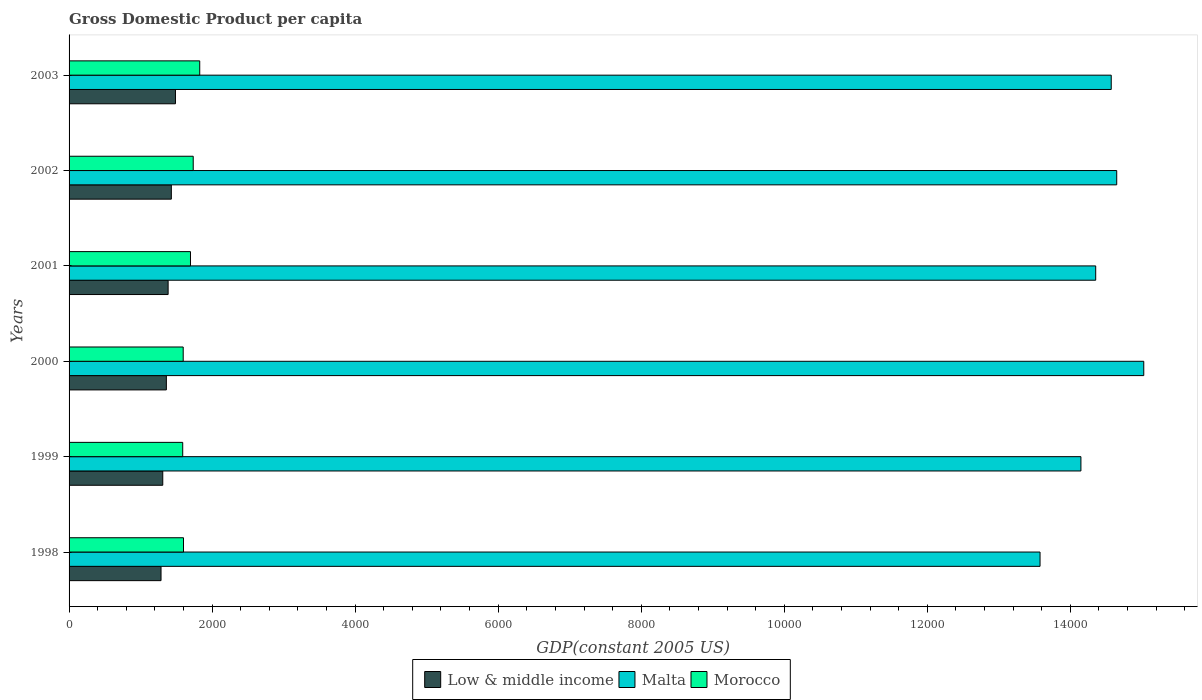How many groups of bars are there?
Your answer should be very brief. 6. Are the number of bars per tick equal to the number of legend labels?
Your answer should be very brief. Yes. Are the number of bars on each tick of the Y-axis equal?
Offer a very short reply. Yes. How many bars are there on the 6th tick from the top?
Your response must be concise. 3. How many bars are there on the 3rd tick from the bottom?
Your response must be concise. 3. In how many cases, is the number of bars for a given year not equal to the number of legend labels?
Make the answer very short. 0. What is the GDP per capita in Low & middle income in 2002?
Make the answer very short. 1430.07. Across all years, what is the maximum GDP per capita in Low & middle income?
Offer a terse response. 1487.72. Across all years, what is the minimum GDP per capita in Morocco?
Give a very brief answer. 1588.98. In which year was the GDP per capita in Low & middle income maximum?
Provide a succinct answer. 2003. What is the total GDP per capita in Morocco in the graph?
Your answer should be very brief. 1.00e+04. What is the difference between the GDP per capita in Low & middle income in 1998 and that in 2002?
Make the answer very short. -144.21. What is the difference between the GDP per capita in Morocco in 1998 and the GDP per capita in Low & middle income in 1999?
Provide a succinct answer. 289.92. What is the average GDP per capita in Morocco per year?
Offer a very short reply. 1674.18. In the year 1998, what is the difference between the GDP per capita in Malta and GDP per capita in Morocco?
Offer a terse response. 1.20e+04. In how many years, is the GDP per capita in Low & middle income greater than 6800 US$?
Provide a succinct answer. 0. What is the ratio of the GDP per capita in Malta in 1998 to that in 1999?
Give a very brief answer. 0.96. Is the GDP per capita in Morocco in 2000 less than that in 2003?
Provide a short and direct response. Yes. What is the difference between the highest and the second highest GDP per capita in Malta?
Your answer should be compact. 377.99. What is the difference between the highest and the lowest GDP per capita in Low & middle income?
Offer a terse response. 201.86. Is the sum of the GDP per capita in Malta in 1999 and 2002 greater than the maximum GDP per capita in Low & middle income across all years?
Your answer should be very brief. Yes. What does the 1st bar from the top in 1999 represents?
Provide a short and direct response. Morocco. What does the 3rd bar from the bottom in 2003 represents?
Offer a terse response. Morocco. Is it the case that in every year, the sum of the GDP per capita in Morocco and GDP per capita in Low & middle income is greater than the GDP per capita in Malta?
Ensure brevity in your answer.  No. How many bars are there?
Provide a succinct answer. 18. Are all the bars in the graph horizontal?
Give a very brief answer. Yes. Are the values on the major ticks of X-axis written in scientific E-notation?
Give a very brief answer. No. Does the graph contain grids?
Provide a short and direct response. No. How are the legend labels stacked?
Provide a short and direct response. Horizontal. What is the title of the graph?
Your response must be concise. Gross Domestic Product per capita. What is the label or title of the X-axis?
Make the answer very short. GDP(constant 2005 US). What is the GDP(constant 2005 US) in Low & middle income in 1998?
Offer a very short reply. 1285.86. What is the GDP(constant 2005 US) of Malta in 1998?
Offer a very short reply. 1.36e+04. What is the GDP(constant 2005 US) of Morocco in 1998?
Keep it short and to the point. 1600.02. What is the GDP(constant 2005 US) of Low & middle income in 1999?
Make the answer very short. 1310.1. What is the GDP(constant 2005 US) in Malta in 1999?
Your response must be concise. 1.41e+04. What is the GDP(constant 2005 US) of Morocco in 1999?
Your answer should be very brief. 1588.98. What is the GDP(constant 2005 US) of Low & middle income in 2000?
Your answer should be compact. 1360.25. What is the GDP(constant 2005 US) in Malta in 2000?
Offer a terse response. 1.50e+04. What is the GDP(constant 2005 US) of Morocco in 2000?
Keep it short and to the point. 1595.77. What is the GDP(constant 2005 US) in Low & middle income in 2001?
Ensure brevity in your answer.  1385.02. What is the GDP(constant 2005 US) of Malta in 2001?
Offer a very short reply. 1.44e+04. What is the GDP(constant 2005 US) in Morocco in 2001?
Provide a succinct answer. 1697.64. What is the GDP(constant 2005 US) of Low & middle income in 2002?
Give a very brief answer. 1430.07. What is the GDP(constant 2005 US) of Malta in 2002?
Provide a succinct answer. 1.46e+04. What is the GDP(constant 2005 US) of Morocco in 2002?
Your answer should be very brief. 1735.79. What is the GDP(constant 2005 US) in Low & middle income in 2003?
Your answer should be compact. 1487.72. What is the GDP(constant 2005 US) of Malta in 2003?
Give a very brief answer. 1.46e+04. What is the GDP(constant 2005 US) in Morocco in 2003?
Keep it short and to the point. 1826.87. Across all years, what is the maximum GDP(constant 2005 US) of Low & middle income?
Your answer should be very brief. 1487.72. Across all years, what is the maximum GDP(constant 2005 US) of Malta?
Ensure brevity in your answer.  1.50e+04. Across all years, what is the maximum GDP(constant 2005 US) in Morocco?
Your answer should be very brief. 1826.87. Across all years, what is the minimum GDP(constant 2005 US) of Low & middle income?
Offer a very short reply. 1285.86. Across all years, what is the minimum GDP(constant 2005 US) of Malta?
Offer a terse response. 1.36e+04. Across all years, what is the minimum GDP(constant 2005 US) in Morocco?
Offer a very short reply. 1588.98. What is the total GDP(constant 2005 US) in Low & middle income in the graph?
Your response must be concise. 8259.01. What is the total GDP(constant 2005 US) of Malta in the graph?
Your answer should be very brief. 8.63e+04. What is the total GDP(constant 2005 US) in Morocco in the graph?
Make the answer very short. 1.00e+04. What is the difference between the GDP(constant 2005 US) of Low & middle income in 1998 and that in 1999?
Offer a very short reply. -24.24. What is the difference between the GDP(constant 2005 US) of Malta in 1998 and that in 1999?
Your answer should be compact. -571.69. What is the difference between the GDP(constant 2005 US) in Morocco in 1998 and that in 1999?
Provide a succinct answer. 11.04. What is the difference between the GDP(constant 2005 US) in Low & middle income in 1998 and that in 2000?
Provide a succinct answer. -74.39. What is the difference between the GDP(constant 2005 US) in Malta in 1998 and that in 2000?
Make the answer very short. -1450.21. What is the difference between the GDP(constant 2005 US) in Morocco in 1998 and that in 2000?
Offer a very short reply. 4.25. What is the difference between the GDP(constant 2005 US) of Low & middle income in 1998 and that in 2001?
Provide a succinct answer. -99.16. What is the difference between the GDP(constant 2005 US) of Malta in 1998 and that in 2001?
Provide a succinct answer. -778.24. What is the difference between the GDP(constant 2005 US) in Morocco in 1998 and that in 2001?
Your answer should be compact. -97.62. What is the difference between the GDP(constant 2005 US) of Low & middle income in 1998 and that in 2002?
Provide a succinct answer. -144.21. What is the difference between the GDP(constant 2005 US) of Malta in 1998 and that in 2002?
Provide a short and direct response. -1072.21. What is the difference between the GDP(constant 2005 US) in Morocco in 1998 and that in 2002?
Give a very brief answer. -135.77. What is the difference between the GDP(constant 2005 US) of Low & middle income in 1998 and that in 2003?
Give a very brief answer. -201.86. What is the difference between the GDP(constant 2005 US) of Malta in 1998 and that in 2003?
Provide a short and direct response. -995.4. What is the difference between the GDP(constant 2005 US) of Morocco in 1998 and that in 2003?
Your answer should be very brief. -226.85. What is the difference between the GDP(constant 2005 US) in Low & middle income in 1999 and that in 2000?
Make the answer very short. -50.15. What is the difference between the GDP(constant 2005 US) of Malta in 1999 and that in 2000?
Provide a succinct answer. -878.51. What is the difference between the GDP(constant 2005 US) of Morocco in 1999 and that in 2000?
Your response must be concise. -6.78. What is the difference between the GDP(constant 2005 US) of Low & middle income in 1999 and that in 2001?
Your answer should be compact. -74.92. What is the difference between the GDP(constant 2005 US) of Malta in 1999 and that in 2001?
Ensure brevity in your answer.  -206.54. What is the difference between the GDP(constant 2005 US) of Morocco in 1999 and that in 2001?
Keep it short and to the point. -108.66. What is the difference between the GDP(constant 2005 US) of Low & middle income in 1999 and that in 2002?
Your answer should be compact. -119.97. What is the difference between the GDP(constant 2005 US) in Malta in 1999 and that in 2002?
Offer a very short reply. -500.52. What is the difference between the GDP(constant 2005 US) of Morocco in 1999 and that in 2002?
Your answer should be very brief. -146.81. What is the difference between the GDP(constant 2005 US) of Low & middle income in 1999 and that in 2003?
Your answer should be very brief. -177.62. What is the difference between the GDP(constant 2005 US) in Malta in 1999 and that in 2003?
Make the answer very short. -423.71. What is the difference between the GDP(constant 2005 US) of Morocco in 1999 and that in 2003?
Offer a terse response. -237.88. What is the difference between the GDP(constant 2005 US) of Low & middle income in 2000 and that in 2001?
Ensure brevity in your answer.  -24.77. What is the difference between the GDP(constant 2005 US) of Malta in 2000 and that in 2001?
Give a very brief answer. 671.97. What is the difference between the GDP(constant 2005 US) of Morocco in 2000 and that in 2001?
Give a very brief answer. -101.88. What is the difference between the GDP(constant 2005 US) in Low & middle income in 2000 and that in 2002?
Ensure brevity in your answer.  -69.82. What is the difference between the GDP(constant 2005 US) of Malta in 2000 and that in 2002?
Offer a very short reply. 377.99. What is the difference between the GDP(constant 2005 US) of Morocco in 2000 and that in 2002?
Make the answer very short. -140.02. What is the difference between the GDP(constant 2005 US) of Low & middle income in 2000 and that in 2003?
Your answer should be very brief. -127.47. What is the difference between the GDP(constant 2005 US) in Malta in 2000 and that in 2003?
Keep it short and to the point. 454.8. What is the difference between the GDP(constant 2005 US) of Morocco in 2000 and that in 2003?
Your answer should be very brief. -231.1. What is the difference between the GDP(constant 2005 US) in Low & middle income in 2001 and that in 2002?
Your answer should be compact. -45.05. What is the difference between the GDP(constant 2005 US) in Malta in 2001 and that in 2002?
Offer a terse response. -293.98. What is the difference between the GDP(constant 2005 US) of Morocco in 2001 and that in 2002?
Your response must be concise. -38.15. What is the difference between the GDP(constant 2005 US) of Low & middle income in 2001 and that in 2003?
Your answer should be very brief. -102.7. What is the difference between the GDP(constant 2005 US) in Malta in 2001 and that in 2003?
Keep it short and to the point. -217.17. What is the difference between the GDP(constant 2005 US) in Morocco in 2001 and that in 2003?
Keep it short and to the point. -129.22. What is the difference between the GDP(constant 2005 US) in Low & middle income in 2002 and that in 2003?
Offer a terse response. -57.65. What is the difference between the GDP(constant 2005 US) in Malta in 2002 and that in 2003?
Offer a terse response. 76.81. What is the difference between the GDP(constant 2005 US) of Morocco in 2002 and that in 2003?
Your response must be concise. -91.08. What is the difference between the GDP(constant 2005 US) in Low & middle income in 1998 and the GDP(constant 2005 US) in Malta in 1999?
Offer a terse response. -1.29e+04. What is the difference between the GDP(constant 2005 US) in Low & middle income in 1998 and the GDP(constant 2005 US) in Morocco in 1999?
Ensure brevity in your answer.  -303.12. What is the difference between the GDP(constant 2005 US) of Malta in 1998 and the GDP(constant 2005 US) of Morocco in 1999?
Keep it short and to the point. 1.20e+04. What is the difference between the GDP(constant 2005 US) in Low & middle income in 1998 and the GDP(constant 2005 US) in Malta in 2000?
Provide a short and direct response. -1.37e+04. What is the difference between the GDP(constant 2005 US) in Low & middle income in 1998 and the GDP(constant 2005 US) in Morocco in 2000?
Provide a succinct answer. -309.91. What is the difference between the GDP(constant 2005 US) of Malta in 1998 and the GDP(constant 2005 US) of Morocco in 2000?
Keep it short and to the point. 1.20e+04. What is the difference between the GDP(constant 2005 US) in Low & middle income in 1998 and the GDP(constant 2005 US) in Malta in 2001?
Provide a short and direct response. -1.31e+04. What is the difference between the GDP(constant 2005 US) in Low & middle income in 1998 and the GDP(constant 2005 US) in Morocco in 2001?
Offer a terse response. -411.78. What is the difference between the GDP(constant 2005 US) in Malta in 1998 and the GDP(constant 2005 US) in Morocco in 2001?
Give a very brief answer. 1.19e+04. What is the difference between the GDP(constant 2005 US) in Low & middle income in 1998 and the GDP(constant 2005 US) in Malta in 2002?
Your answer should be compact. -1.34e+04. What is the difference between the GDP(constant 2005 US) in Low & middle income in 1998 and the GDP(constant 2005 US) in Morocco in 2002?
Your answer should be compact. -449.93. What is the difference between the GDP(constant 2005 US) in Malta in 1998 and the GDP(constant 2005 US) in Morocco in 2002?
Your answer should be very brief. 1.18e+04. What is the difference between the GDP(constant 2005 US) of Low & middle income in 1998 and the GDP(constant 2005 US) of Malta in 2003?
Ensure brevity in your answer.  -1.33e+04. What is the difference between the GDP(constant 2005 US) of Low & middle income in 1998 and the GDP(constant 2005 US) of Morocco in 2003?
Your response must be concise. -541.01. What is the difference between the GDP(constant 2005 US) of Malta in 1998 and the GDP(constant 2005 US) of Morocco in 2003?
Provide a short and direct response. 1.17e+04. What is the difference between the GDP(constant 2005 US) in Low & middle income in 1999 and the GDP(constant 2005 US) in Malta in 2000?
Make the answer very short. -1.37e+04. What is the difference between the GDP(constant 2005 US) in Low & middle income in 1999 and the GDP(constant 2005 US) in Morocco in 2000?
Offer a terse response. -285.67. What is the difference between the GDP(constant 2005 US) in Malta in 1999 and the GDP(constant 2005 US) in Morocco in 2000?
Your answer should be compact. 1.26e+04. What is the difference between the GDP(constant 2005 US) of Low & middle income in 1999 and the GDP(constant 2005 US) of Malta in 2001?
Give a very brief answer. -1.30e+04. What is the difference between the GDP(constant 2005 US) in Low & middle income in 1999 and the GDP(constant 2005 US) in Morocco in 2001?
Your answer should be very brief. -387.55. What is the difference between the GDP(constant 2005 US) in Malta in 1999 and the GDP(constant 2005 US) in Morocco in 2001?
Offer a very short reply. 1.25e+04. What is the difference between the GDP(constant 2005 US) of Low & middle income in 1999 and the GDP(constant 2005 US) of Malta in 2002?
Offer a very short reply. -1.33e+04. What is the difference between the GDP(constant 2005 US) in Low & middle income in 1999 and the GDP(constant 2005 US) in Morocco in 2002?
Your answer should be very brief. -425.69. What is the difference between the GDP(constant 2005 US) of Malta in 1999 and the GDP(constant 2005 US) of Morocco in 2002?
Provide a succinct answer. 1.24e+04. What is the difference between the GDP(constant 2005 US) of Low & middle income in 1999 and the GDP(constant 2005 US) of Malta in 2003?
Give a very brief answer. -1.33e+04. What is the difference between the GDP(constant 2005 US) of Low & middle income in 1999 and the GDP(constant 2005 US) of Morocco in 2003?
Your answer should be very brief. -516.77. What is the difference between the GDP(constant 2005 US) of Malta in 1999 and the GDP(constant 2005 US) of Morocco in 2003?
Provide a succinct answer. 1.23e+04. What is the difference between the GDP(constant 2005 US) of Low & middle income in 2000 and the GDP(constant 2005 US) of Malta in 2001?
Keep it short and to the point. -1.30e+04. What is the difference between the GDP(constant 2005 US) of Low & middle income in 2000 and the GDP(constant 2005 US) of Morocco in 2001?
Offer a very short reply. -337.4. What is the difference between the GDP(constant 2005 US) of Malta in 2000 and the GDP(constant 2005 US) of Morocco in 2001?
Provide a short and direct response. 1.33e+04. What is the difference between the GDP(constant 2005 US) in Low & middle income in 2000 and the GDP(constant 2005 US) in Malta in 2002?
Your answer should be compact. -1.33e+04. What is the difference between the GDP(constant 2005 US) of Low & middle income in 2000 and the GDP(constant 2005 US) of Morocco in 2002?
Give a very brief answer. -375.54. What is the difference between the GDP(constant 2005 US) of Malta in 2000 and the GDP(constant 2005 US) of Morocco in 2002?
Offer a very short reply. 1.33e+04. What is the difference between the GDP(constant 2005 US) of Low & middle income in 2000 and the GDP(constant 2005 US) of Malta in 2003?
Your answer should be compact. -1.32e+04. What is the difference between the GDP(constant 2005 US) in Low & middle income in 2000 and the GDP(constant 2005 US) in Morocco in 2003?
Offer a very short reply. -466.62. What is the difference between the GDP(constant 2005 US) in Malta in 2000 and the GDP(constant 2005 US) in Morocco in 2003?
Make the answer very short. 1.32e+04. What is the difference between the GDP(constant 2005 US) in Low & middle income in 2001 and the GDP(constant 2005 US) in Malta in 2002?
Your answer should be compact. -1.33e+04. What is the difference between the GDP(constant 2005 US) of Low & middle income in 2001 and the GDP(constant 2005 US) of Morocco in 2002?
Your response must be concise. -350.77. What is the difference between the GDP(constant 2005 US) of Malta in 2001 and the GDP(constant 2005 US) of Morocco in 2002?
Offer a terse response. 1.26e+04. What is the difference between the GDP(constant 2005 US) of Low & middle income in 2001 and the GDP(constant 2005 US) of Malta in 2003?
Ensure brevity in your answer.  -1.32e+04. What is the difference between the GDP(constant 2005 US) in Low & middle income in 2001 and the GDP(constant 2005 US) in Morocco in 2003?
Your response must be concise. -441.85. What is the difference between the GDP(constant 2005 US) of Malta in 2001 and the GDP(constant 2005 US) of Morocco in 2003?
Your answer should be compact. 1.25e+04. What is the difference between the GDP(constant 2005 US) in Low & middle income in 2002 and the GDP(constant 2005 US) in Malta in 2003?
Offer a very short reply. -1.31e+04. What is the difference between the GDP(constant 2005 US) of Low & middle income in 2002 and the GDP(constant 2005 US) of Morocco in 2003?
Keep it short and to the point. -396.8. What is the difference between the GDP(constant 2005 US) in Malta in 2002 and the GDP(constant 2005 US) in Morocco in 2003?
Ensure brevity in your answer.  1.28e+04. What is the average GDP(constant 2005 US) in Low & middle income per year?
Give a very brief answer. 1376.5. What is the average GDP(constant 2005 US) in Malta per year?
Offer a very short reply. 1.44e+04. What is the average GDP(constant 2005 US) of Morocco per year?
Give a very brief answer. 1674.18. In the year 1998, what is the difference between the GDP(constant 2005 US) in Low & middle income and GDP(constant 2005 US) in Malta?
Offer a terse response. -1.23e+04. In the year 1998, what is the difference between the GDP(constant 2005 US) in Low & middle income and GDP(constant 2005 US) in Morocco?
Your answer should be very brief. -314.16. In the year 1998, what is the difference between the GDP(constant 2005 US) in Malta and GDP(constant 2005 US) in Morocco?
Offer a very short reply. 1.20e+04. In the year 1999, what is the difference between the GDP(constant 2005 US) of Low & middle income and GDP(constant 2005 US) of Malta?
Your answer should be compact. -1.28e+04. In the year 1999, what is the difference between the GDP(constant 2005 US) of Low & middle income and GDP(constant 2005 US) of Morocco?
Your answer should be very brief. -278.89. In the year 1999, what is the difference between the GDP(constant 2005 US) in Malta and GDP(constant 2005 US) in Morocco?
Your response must be concise. 1.26e+04. In the year 2000, what is the difference between the GDP(constant 2005 US) of Low & middle income and GDP(constant 2005 US) of Malta?
Your answer should be very brief. -1.37e+04. In the year 2000, what is the difference between the GDP(constant 2005 US) of Low & middle income and GDP(constant 2005 US) of Morocco?
Offer a terse response. -235.52. In the year 2000, what is the difference between the GDP(constant 2005 US) of Malta and GDP(constant 2005 US) of Morocco?
Your answer should be compact. 1.34e+04. In the year 2001, what is the difference between the GDP(constant 2005 US) in Low & middle income and GDP(constant 2005 US) in Malta?
Your answer should be very brief. -1.30e+04. In the year 2001, what is the difference between the GDP(constant 2005 US) in Low & middle income and GDP(constant 2005 US) in Morocco?
Provide a succinct answer. -312.62. In the year 2001, what is the difference between the GDP(constant 2005 US) of Malta and GDP(constant 2005 US) of Morocco?
Keep it short and to the point. 1.27e+04. In the year 2002, what is the difference between the GDP(constant 2005 US) of Low & middle income and GDP(constant 2005 US) of Malta?
Provide a succinct answer. -1.32e+04. In the year 2002, what is the difference between the GDP(constant 2005 US) of Low & middle income and GDP(constant 2005 US) of Morocco?
Your answer should be compact. -305.72. In the year 2002, what is the difference between the GDP(constant 2005 US) in Malta and GDP(constant 2005 US) in Morocco?
Your answer should be compact. 1.29e+04. In the year 2003, what is the difference between the GDP(constant 2005 US) in Low & middle income and GDP(constant 2005 US) in Malta?
Keep it short and to the point. -1.31e+04. In the year 2003, what is the difference between the GDP(constant 2005 US) in Low & middle income and GDP(constant 2005 US) in Morocco?
Keep it short and to the point. -339.15. In the year 2003, what is the difference between the GDP(constant 2005 US) in Malta and GDP(constant 2005 US) in Morocco?
Provide a short and direct response. 1.27e+04. What is the ratio of the GDP(constant 2005 US) of Low & middle income in 1998 to that in 1999?
Keep it short and to the point. 0.98. What is the ratio of the GDP(constant 2005 US) in Malta in 1998 to that in 1999?
Offer a terse response. 0.96. What is the ratio of the GDP(constant 2005 US) of Low & middle income in 1998 to that in 2000?
Offer a terse response. 0.95. What is the ratio of the GDP(constant 2005 US) of Malta in 1998 to that in 2000?
Ensure brevity in your answer.  0.9. What is the ratio of the GDP(constant 2005 US) in Low & middle income in 1998 to that in 2001?
Provide a succinct answer. 0.93. What is the ratio of the GDP(constant 2005 US) in Malta in 1998 to that in 2001?
Your answer should be very brief. 0.95. What is the ratio of the GDP(constant 2005 US) of Morocco in 1998 to that in 2001?
Provide a short and direct response. 0.94. What is the ratio of the GDP(constant 2005 US) of Low & middle income in 1998 to that in 2002?
Offer a terse response. 0.9. What is the ratio of the GDP(constant 2005 US) in Malta in 1998 to that in 2002?
Give a very brief answer. 0.93. What is the ratio of the GDP(constant 2005 US) in Morocco in 1998 to that in 2002?
Your answer should be very brief. 0.92. What is the ratio of the GDP(constant 2005 US) of Low & middle income in 1998 to that in 2003?
Your response must be concise. 0.86. What is the ratio of the GDP(constant 2005 US) of Malta in 1998 to that in 2003?
Keep it short and to the point. 0.93. What is the ratio of the GDP(constant 2005 US) of Morocco in 1998 to that in 2003?
Keep it short and to the point. 0.88. What is the ratio of the GDP(constant 2005 US) of Low & middle income in 1999 to that in 2000?
Provide a short and direct response. 0.96. What is the ratio of the GDP(constant 2005 US) of Malta in 1999 to that in 2000?
Your response must be concise. 0.94. What is the ratio of the GDP(constant 2005 US) in Low & middle income in 1999 to that in 2001?
Provide a short and direct response. 0.95. What is the ratio of the GDP(constant 2005 US) in Malta in 1999 to that in 2001?
Your answer should be compact. 0.99. What is the ratio of the GDP(constant 2005 US) in Morocco in 1999 to that in 2001?
Make the answer very short. 0.94. What is the ratio of the GDP(constant 2005 US) of Low & middle income in 1999 to that in 2002?
Offer a terse response. 0.92. What is the ratio of the GDP(constant 2005 US) of Malta in 1999 to that in 2002?
Give a very brief answer. 0.97. What is the ratio of the GDP(constant 2005 US) of Morocco in 1999 to that in 2002?
Your answer should be compact. 0.92. What is the ratio of the GDP(constant 2005 US) of Low & middle income in 1999 to that in 2003?
Ensure brevity in your answer.  0.88. What is the ratio of the GDP(constant 2005 US) of Malta in 1999 to that in 2003?
Your response must be concise. 0.97. What is the ratio of the GDP(constant 2005 US) in Morocco in 1999 to that in 2003?
Ensure brevity in your answer.  0.87. What is the ratio of the GDP(constant 2005 US) in Low & middle income in 2000 to that in 2001?
Your answer should be very brief. 0.98. What is the ratio of the GDP(constant 2005 US) of Malta in 2000 to that in 2001?
Offer a very short reply. 1.05. What is the ratio of the GDP(constant 2005 US) of Low & middle income in 2000 to that in 2002?
Keep it short and to the point. 0.95. What is the ratio of the GDP(constant 2005 US) of Malta in 2000 to that in 2002?
Keep it short and to the point. 1.03. What is the ratio of the GDP(constant 2005 US) in Morocco in 2000 to that in 2002?
Your answer should be compact. 0.92. What is the ratio of the GDP(constant 2005 US) in Low & middle income in 2000 to that in 2003?
Keep it short and to the point. 0.91. What is the ratio of the GDP(constant 2005 US) in Malta in 2000 to that in 2003?
Offer a very short reply. 1.03. What is the ratio of the GDP(constant 2005 US) in Morocco in 2000 to that in 2003?
Provide a short and direct response. 0.87. What is the ratio of the GDP(constant 2005 US) in Low & middle income in 2001 to that in 2002?
Your answer should be very brief. 0.97. What is the ratio of the GDP(constant 2005 US) of Malta in 2001 to that in 2002?
Provide a short and direct response. 0.98. What is the ratio of the GDP(constant 2005 US) of Malta in 2001 to that in 2003?
Offer a very short reply. 0.99. What is the ratio of the GDP(constant 2005 US) of Morocco in 2001 to that in 2003?
Your response must be concise. 0.93. What is the ratio of the GDP(constant 2005 US) of Low & middle income in 2002 to that in 2003?
Provide a short and direct response. 0.96. What is the ratio of the GDP(constant 2005 US) in Morocco in 2002 to that in 2003?
Give a very brief answer. 0.95. What is the difference between the highest and the second highest GDP(constant 2005 US) in Low & middle income?
Your answer should be compact. 57.65. What is the difference between the highest and the second highest GDP(constant 2005 US) of Malta?
Your answer should be very brief. 377.99. What is the difference between the highest and the second highest GDP(constant 2005 US) in Morocco?
Give a very brief answer. 91.08. What is the difference between the highest and the lowest GDP(constant 2005 US) in Low & middle income?
Offer a very short reply. 201.86. What is the difference between the highest and the lowest GDP(constant 2005 US) of Malta?
Keep it short and to the point. 1450.21. What is the difference between the highest and the lowest GDP(constant 2005 US) in Morocco?
Your answer should be very brief. 237.88. 